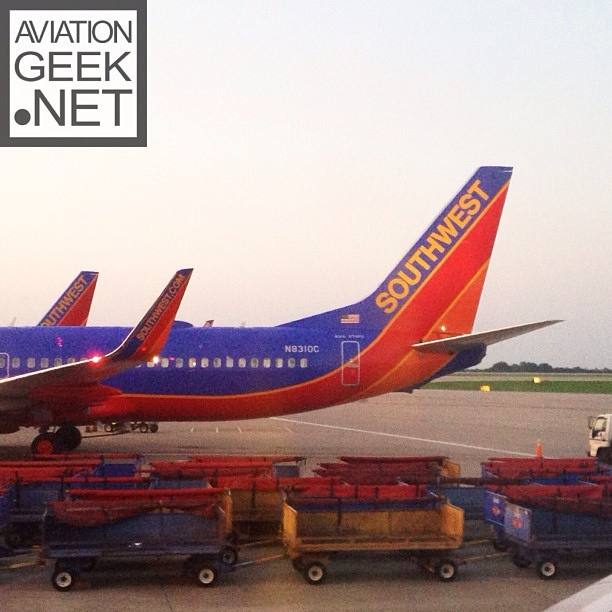Describe the objects in this image and their specific colors. I can see airplane in gray, maroon, brown, purple, and red tones, truck in gray, maroon, black, and brown tones, truck in gray and black tones, truck in gray, black, and maroon tones, and truck in gray, black, and tan tones in this image. 